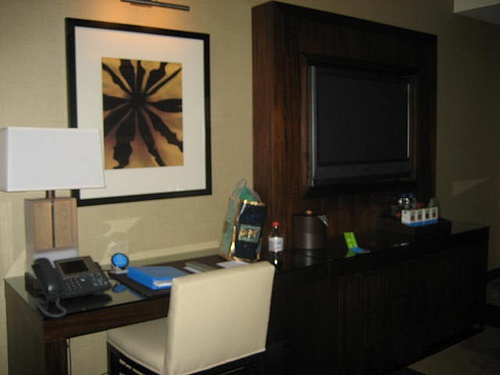Describe the objects in this image and their specific colors. I can see chair in gray and tan tones, tv in black and gray tones, bottle in gray, black, and tan tones, book in gray, blue, and darkgray tones, and bottle in gray, black, darkgray, and maroon tones in this image. 